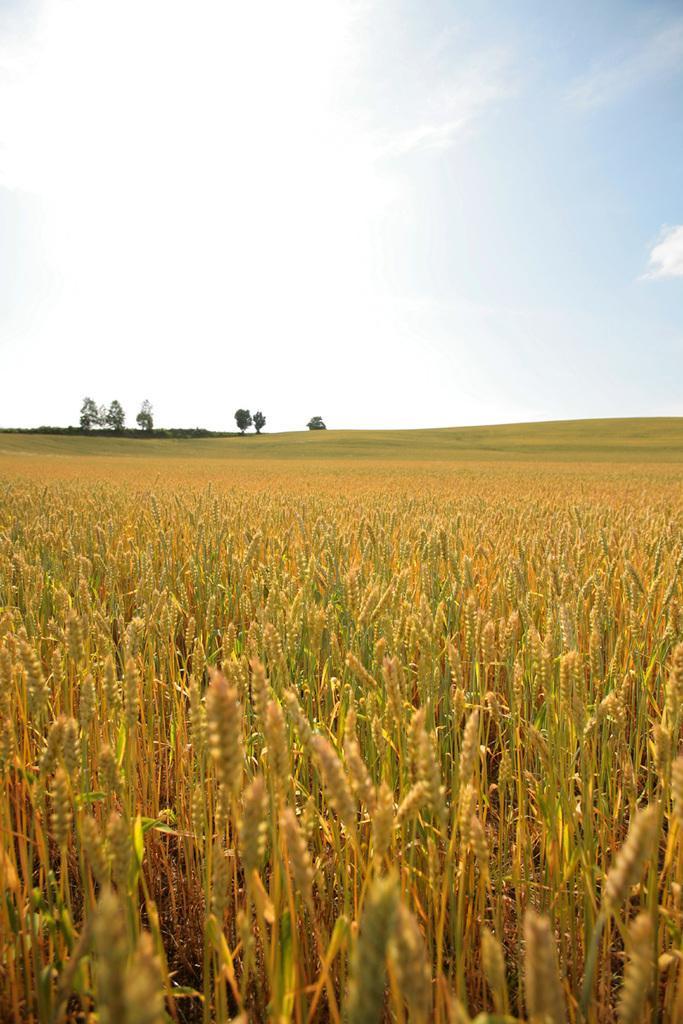In one or two sentences, can you explain what this image depicts? In this image we can see farmlands of wheat grains and in the background of the image there are some trees and clear sky. 